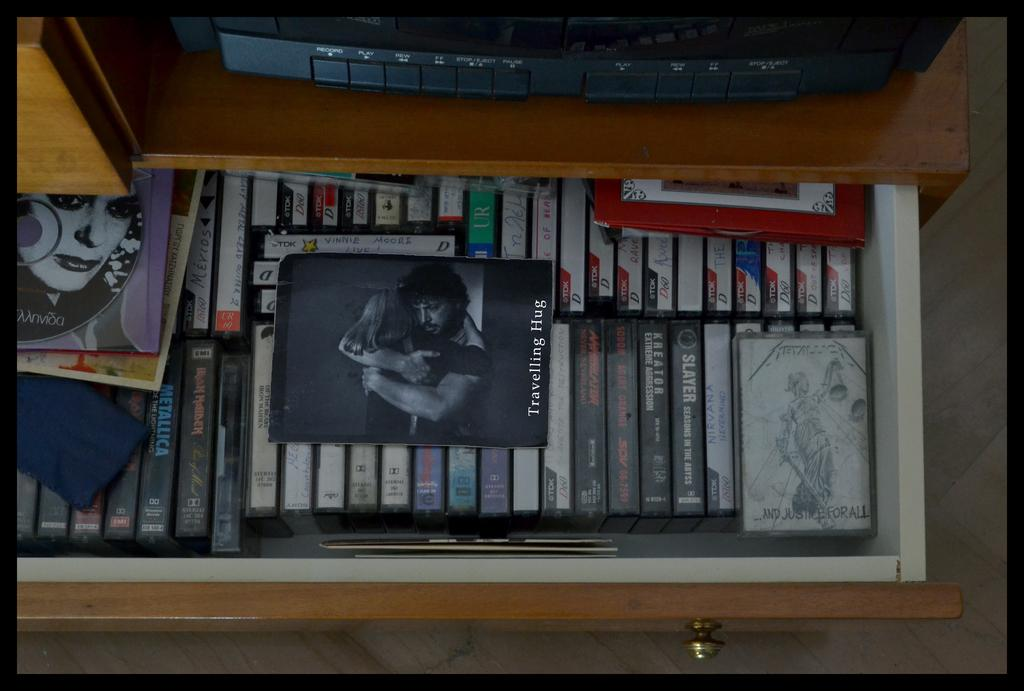Provide a one-sentence caption for the provided image. A drawer full of movies is pulled out and has "Traveling Hugs" sitting on top of the other movies. 